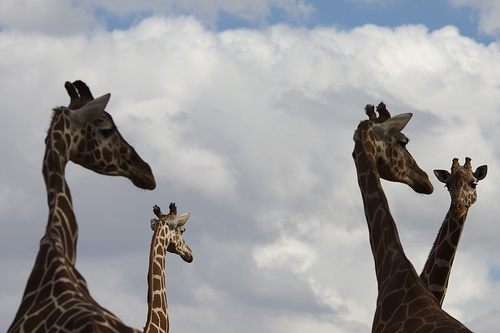Describe the objects in this image and their specific colors. I can see giraffe in darkgray, black, and gray tones, giraffe in darkgray, black, and maroon tones, giraffe in darkgray, black, maroon, and gray tones, and giraffe in darkgray, maroon, black, and tan tones in this image. 